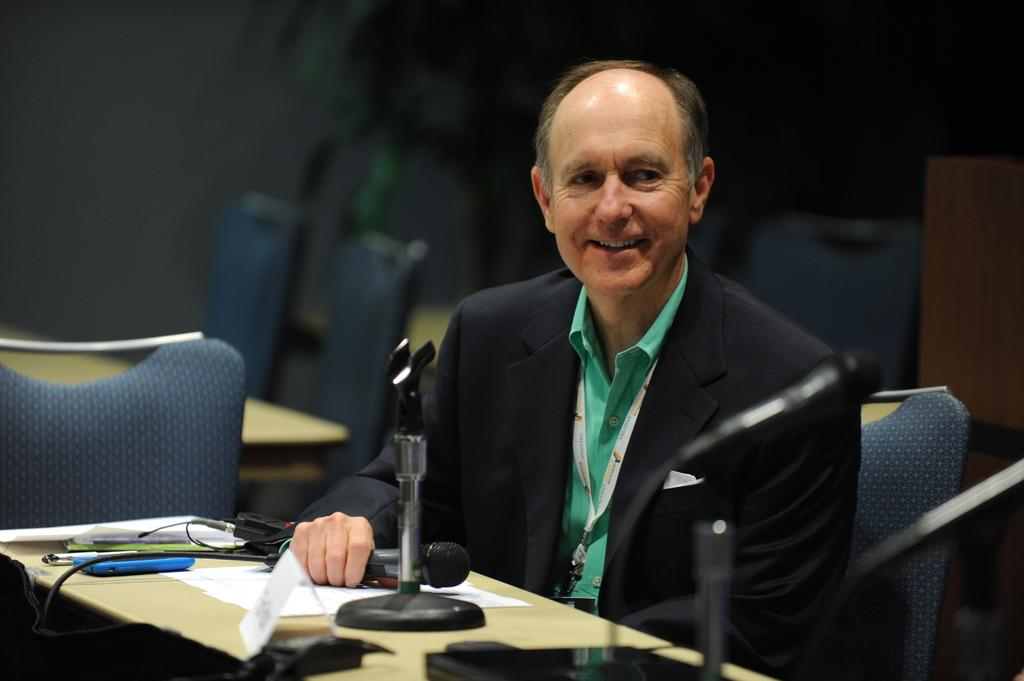What type of furniture is present in the image? There are chairs and tables in the image. What is the man in the image doing? The man is sitting on a chair. What objects can be seen on the table in the image? There is a mobile phone, a pen, and papers on the table. Can you see a crown on the man's head in the image? No, there is no crown present on the man's head in the image. Is there a wren perched on the table in the image? No, there is no wren present in the image. 